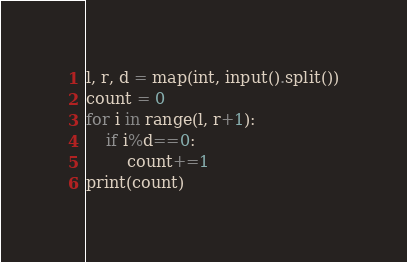<code> <loc_0><loc_0><loc_500><loc_500><_Python_>l, r, d = map(int, input().split())
count = 0
for i in range(l, r+1):
    if i%d==0:
        count+=1
print(count)</code> 